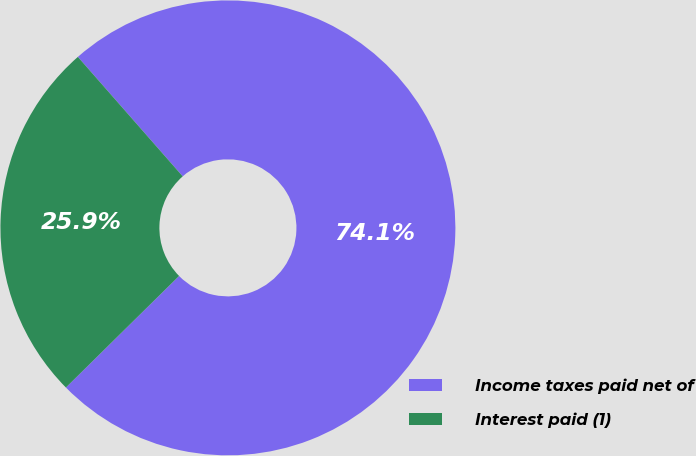Convert chart. <chart><loc_0><loc_0><loc_500><loc_500><pie_chart><fcel>Income taxes paid net of<fcel>Interest paid (1)<nl><fcel>74.08%<fcel>25.92%<nl></chart> 